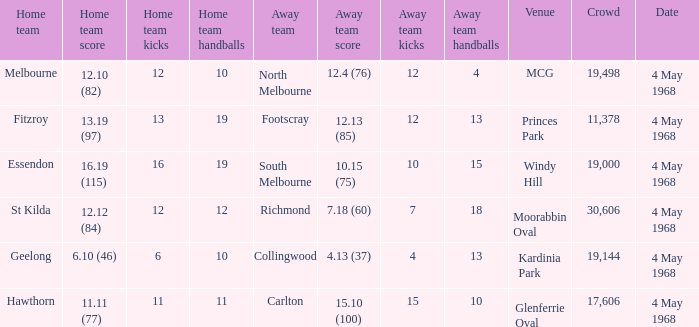What away team played at Kardinia Park? 4.13 (37). 